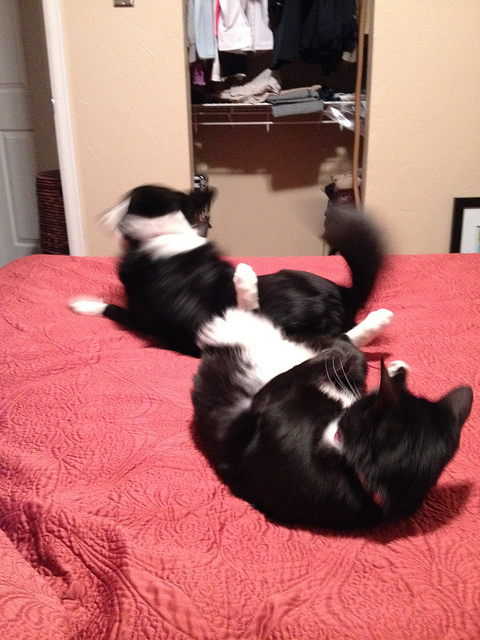What might be the relationship between these two cats? Judging by their interactions and proximity, it's likely that these two cats share a close bond. They could be from the same household, where they have grown accustomed to each other's presence. Their playful behavior suggests they're comfortable and familiar with one another, likely indicating that they are pets who may be siblings or simply share a strong friendship. 